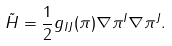<formula> <loc_0><loc_0><loc_500><loc_500>\tilde { H } = { \frac { 1 } { 2 } } g _ { I J } ( \pi ) \nabla \pi ^ { I } \nabla \pi ^ { J } .</formula> 